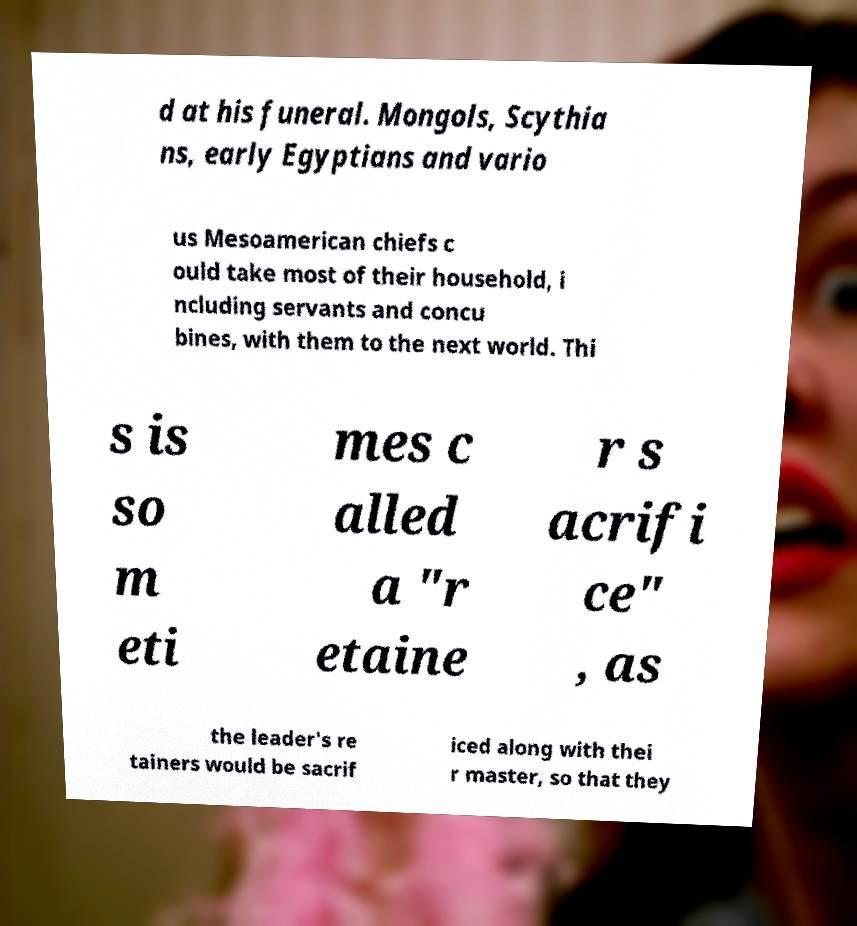Please read and relay the text visible in this image. What does it say? d at his funeral. Mongols, Scythia ns, early Egyptians and vario us Mesoamerican chiefs c ould take most of their household, i ncluding servants and concu bines, with them to the next world. Thi s is so m eti mes c alled a "r etaine r s acrifi ce" , as the leader's re tainers would be sacrif iced along with thei r master, so that they 